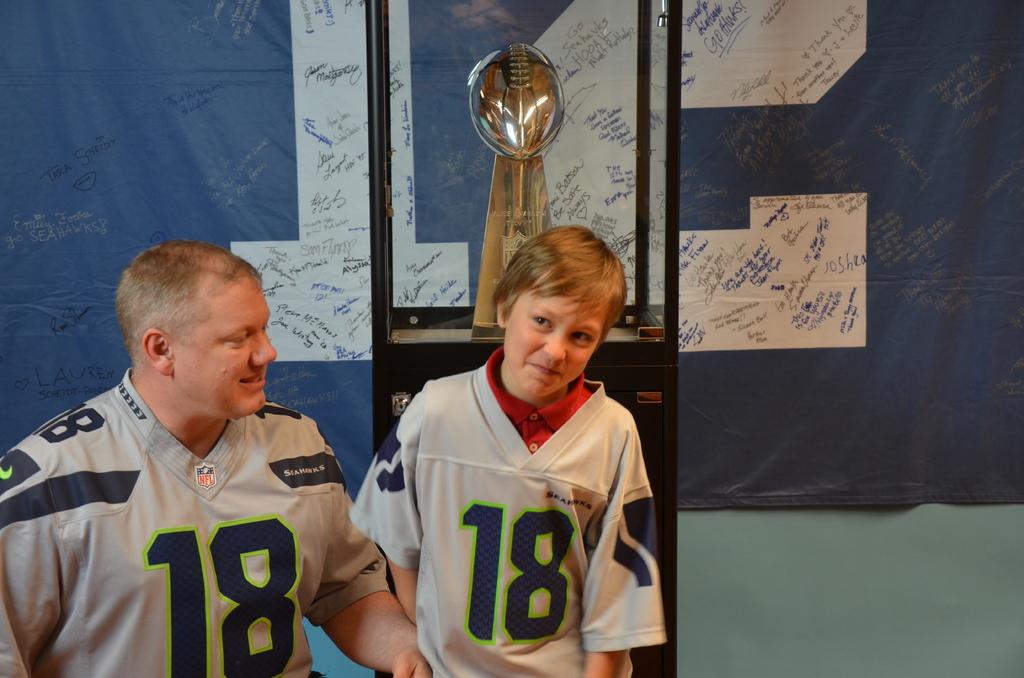What jersey number is on both jerseys?
Keep it short and to the point. 18. 